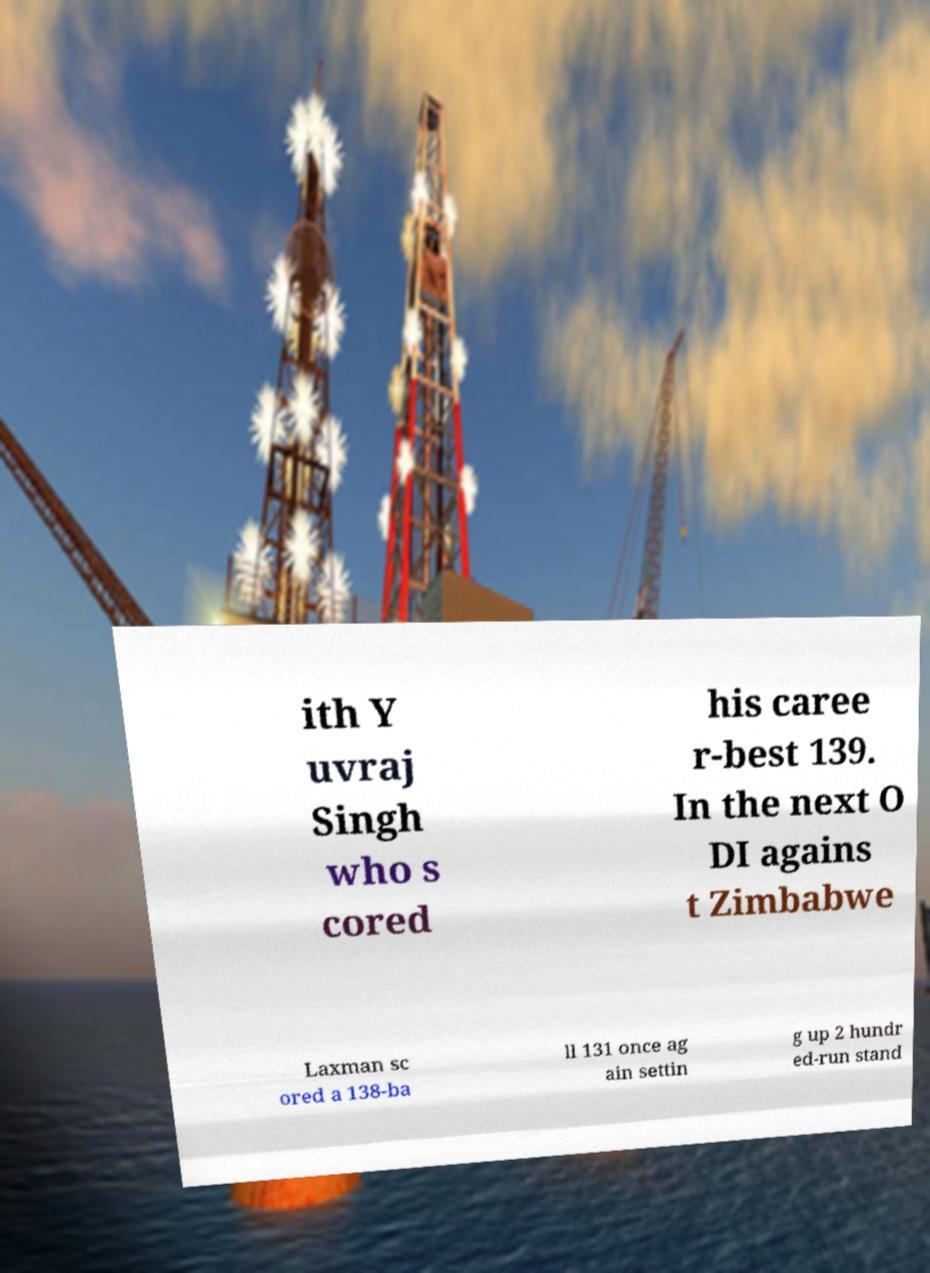I need the written content from this picture converted into text. Can you do that? ith Y uvraj Singh who s cored his caree r-best 139. In the next O DI agains t Zimbabwe Laxman sc ored a 138-ba ll 131 once ag ain settin g up 2 hundr ed-run stand 